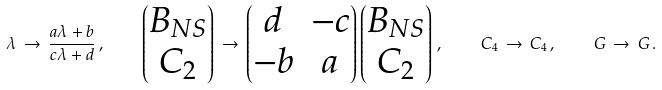Convert formula to latex. <formula><loc_0><loc_0><loc_500><loc_500>\lambda \, \to \, \frac { a \lambda + b } { c \lambda + d } \, , \quad \begin{pmatrix} B _ { N S } \\ C _ { 2 } \end{pmatrix} \, \to \, \begin{pmatrix} d & - c \\ - b & a \end{pmatrix} \begin{pmatrix} B _ { N S } \\ C _ { 2 } \end{pmatrix} \, , \quad C _ { 4 } \, \to \, C _ { 4 } \, , \quad G \, \to \, G \, .</formula> 